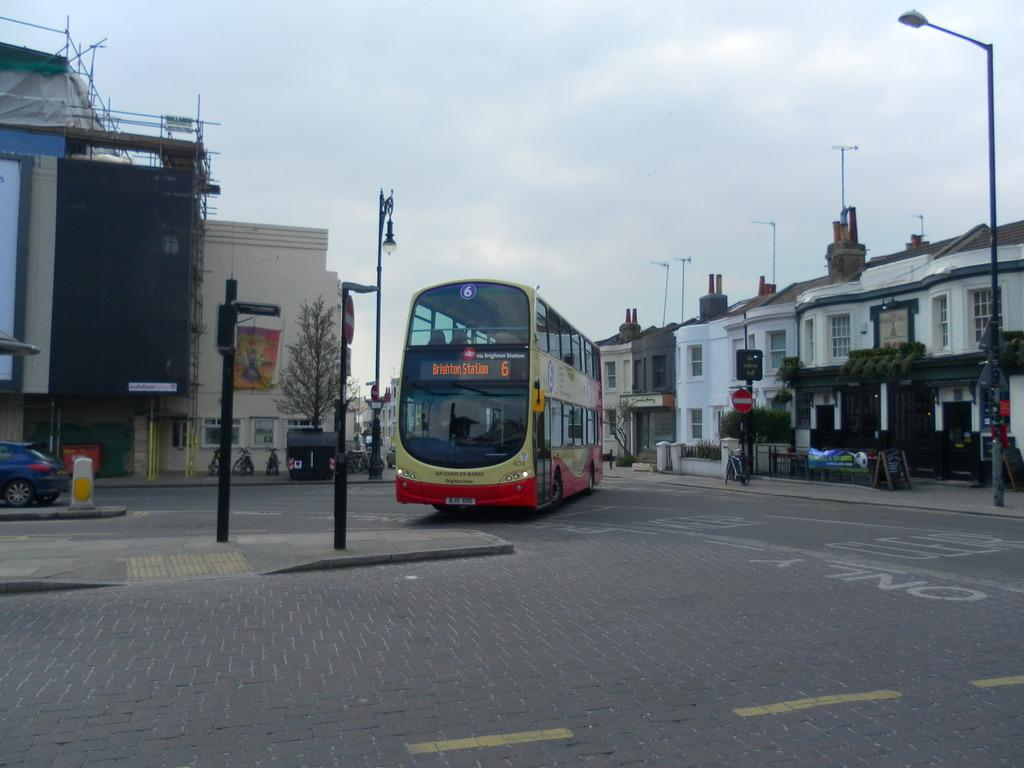How many vehicles can be seen on the road in the image? There are three vehicles on the road in the image. What other types of transportation are present on the road? Bicycles are also present on the road. What structures can be seen in the background of the image? Buildings are visible in the image. What objects are used to provide information or directions in the image? Sign boards are present in the image. What is used to illuminate the road at night in the image? Street lights are visible in the image. What type of vertical structures are present in the image? Poles are present in the image. What can be seen in the sky in the image? There are clouds in the sky. What type of credit card is being used to purchase a banana in the image? There is no credit card or banana present in the image. What color is the ink used to write on the sign board in the image? There is no mention of ink or writing on the sign board in the image. 